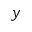<formula> <loc_0><loc_0><loc_500><loc_500>y</formula> 